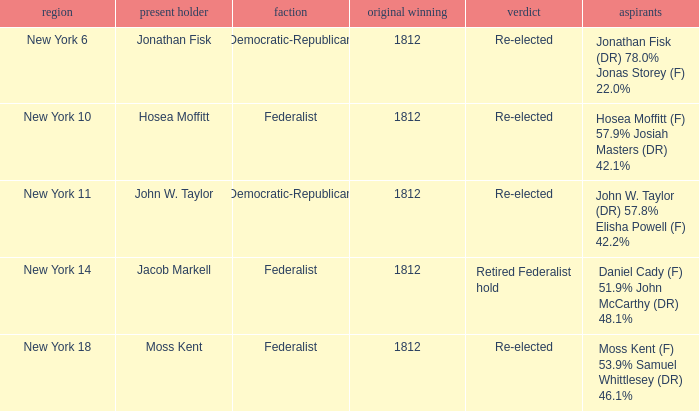9% josiah masters (dr) 4 1812.0. 